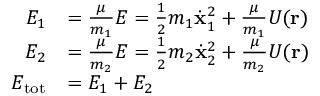Convert formula to latex. <formula><loc_0><loc_0><loc_500><loc_500>{ \begin{array} { r l } { E _ { 1 } } & { = { \frac { \mu } { m _ { 1 } } } E = { \frac { 1 } { 2 } } m _ { 1 } { \dot { x } } _ { 1 } ^ { 2 } + { \frac { \mu } { m _ { 1 } } } U ( r ) } \\ { E _ { 2 } } & { = { \frac { \mu } { m _ { 2 } } } E = { \frac { 1 } { 2 } } m _ { 2 } { \dot { x } } _ { 2 } ^ { 2 } + { \frac { \mu } { m _ { 2 } } } U ( r ) } \\ { E _ { t o t } } & { = E _ { 1 } + E _ { 2 } } \end{array} }</formula> 